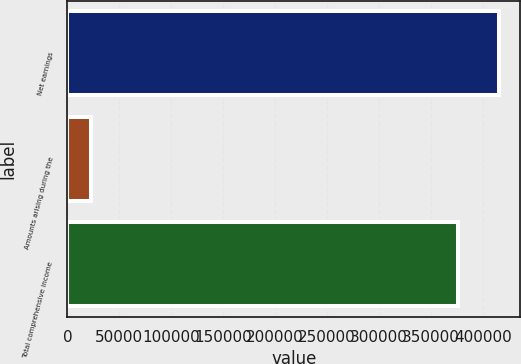Convert chart. <chart><loc_0><loc_0><loc_500><loc_500><bar_chart><fcel>Net earnings<fcel>Amounts arising during the<fcel>Total comprehensive income<nl><fcel>415513<fcel>22591<fcel>376393<nl></chart> 